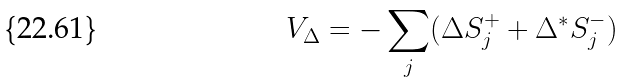<formula> <loc_0><loc_0><loc_500><loc_500>V _ { \Delta } = - \sum _ { j } ( \Delta S _ { j } ^ { + } + \Delta ^ { \ast } S _ { j } ^ { - } )</formula> 